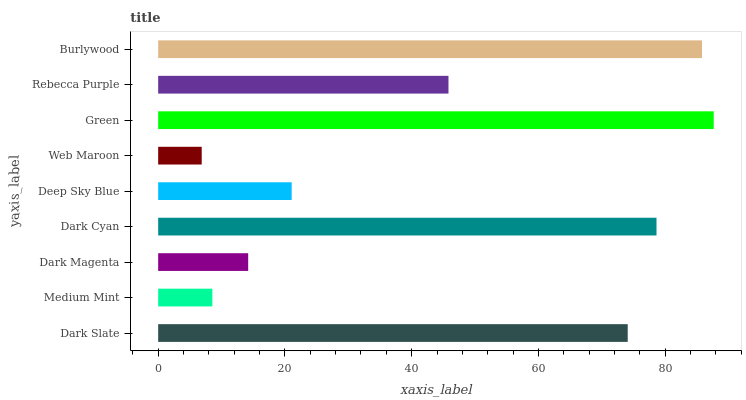Is Web Maroon the minimum?
Answer yes or no. Yes. Is Green the maximum?
Answer yes or no. Yes. Is Medium Mint the minimum?
Answer yes or no. No. Is Medium Mint the maximum?
Answer yes or no. No. Is Dark Slate greater than Medium Mint?
Answer yes or no. Yes. Is Medium Mint less than Dark Slate?
Answer yes or no. Yes. Is Medium Mint greater than Dark Slate?
Answer yes or no. No. Is Dark Slate less than Medium Mint?
Answer yes or no. No. Is Rebecca Purple the high median?
Answer yes or no. Yes. Is Rebecca Purple the low median?
Answer yes or no. Yes. Is Web Maroon the high median?
Answer yes or no. No. Is Dark Magenta the low median?
Answer yes or no. No. 